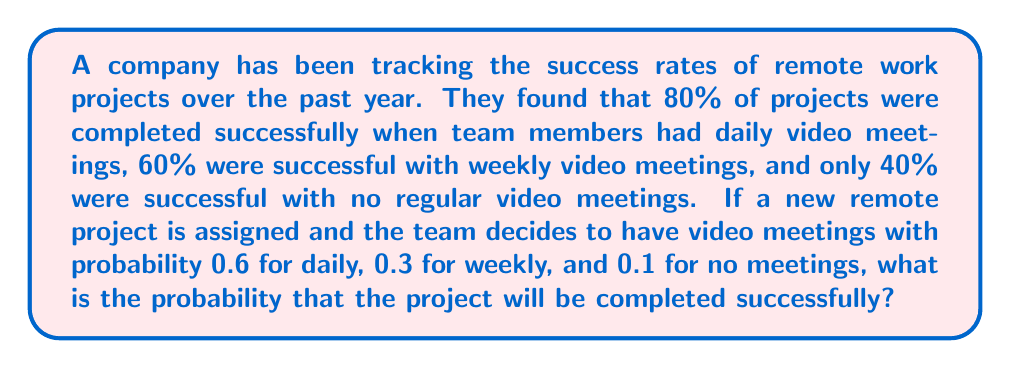Teach me how to tackle this problem. Let's approach this step-by-step using the law of total probability:

1) Define events:
   A: Project is completed successfully
   D: Daily video meetings
   W: Weekly video meetings
   N: No regular video meetings

2) Given probabilities:
   P(A|D) = 0.80
   P(A|W) = 0.60
   P(A|N) = 0.40
   P(D) = 0.6
   P(W) = 0.3
   P(N) = 0.1

3) Apply the law of total probability:
   $$P(A) = P(A|D)P(D) + P(A|W)P(W) + P(A|N)P(N)$$

4) Substitute the values:
   $$P(A) = (0.80)(0.6) + (0.60)(0.3) + (0.40)(0.1)$$

5) Calculate:
   $$P(A) = 0.48 + 0.18 + 0.04 = 0.70$$

Therefore, the probability that the project will be completed successfully is 0.70 or 70%.
Answer: 0.70 